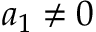<formula> <loc_0><loc_0><loc_500><loc_500>a _ { 1 } \neq 0</formula> 